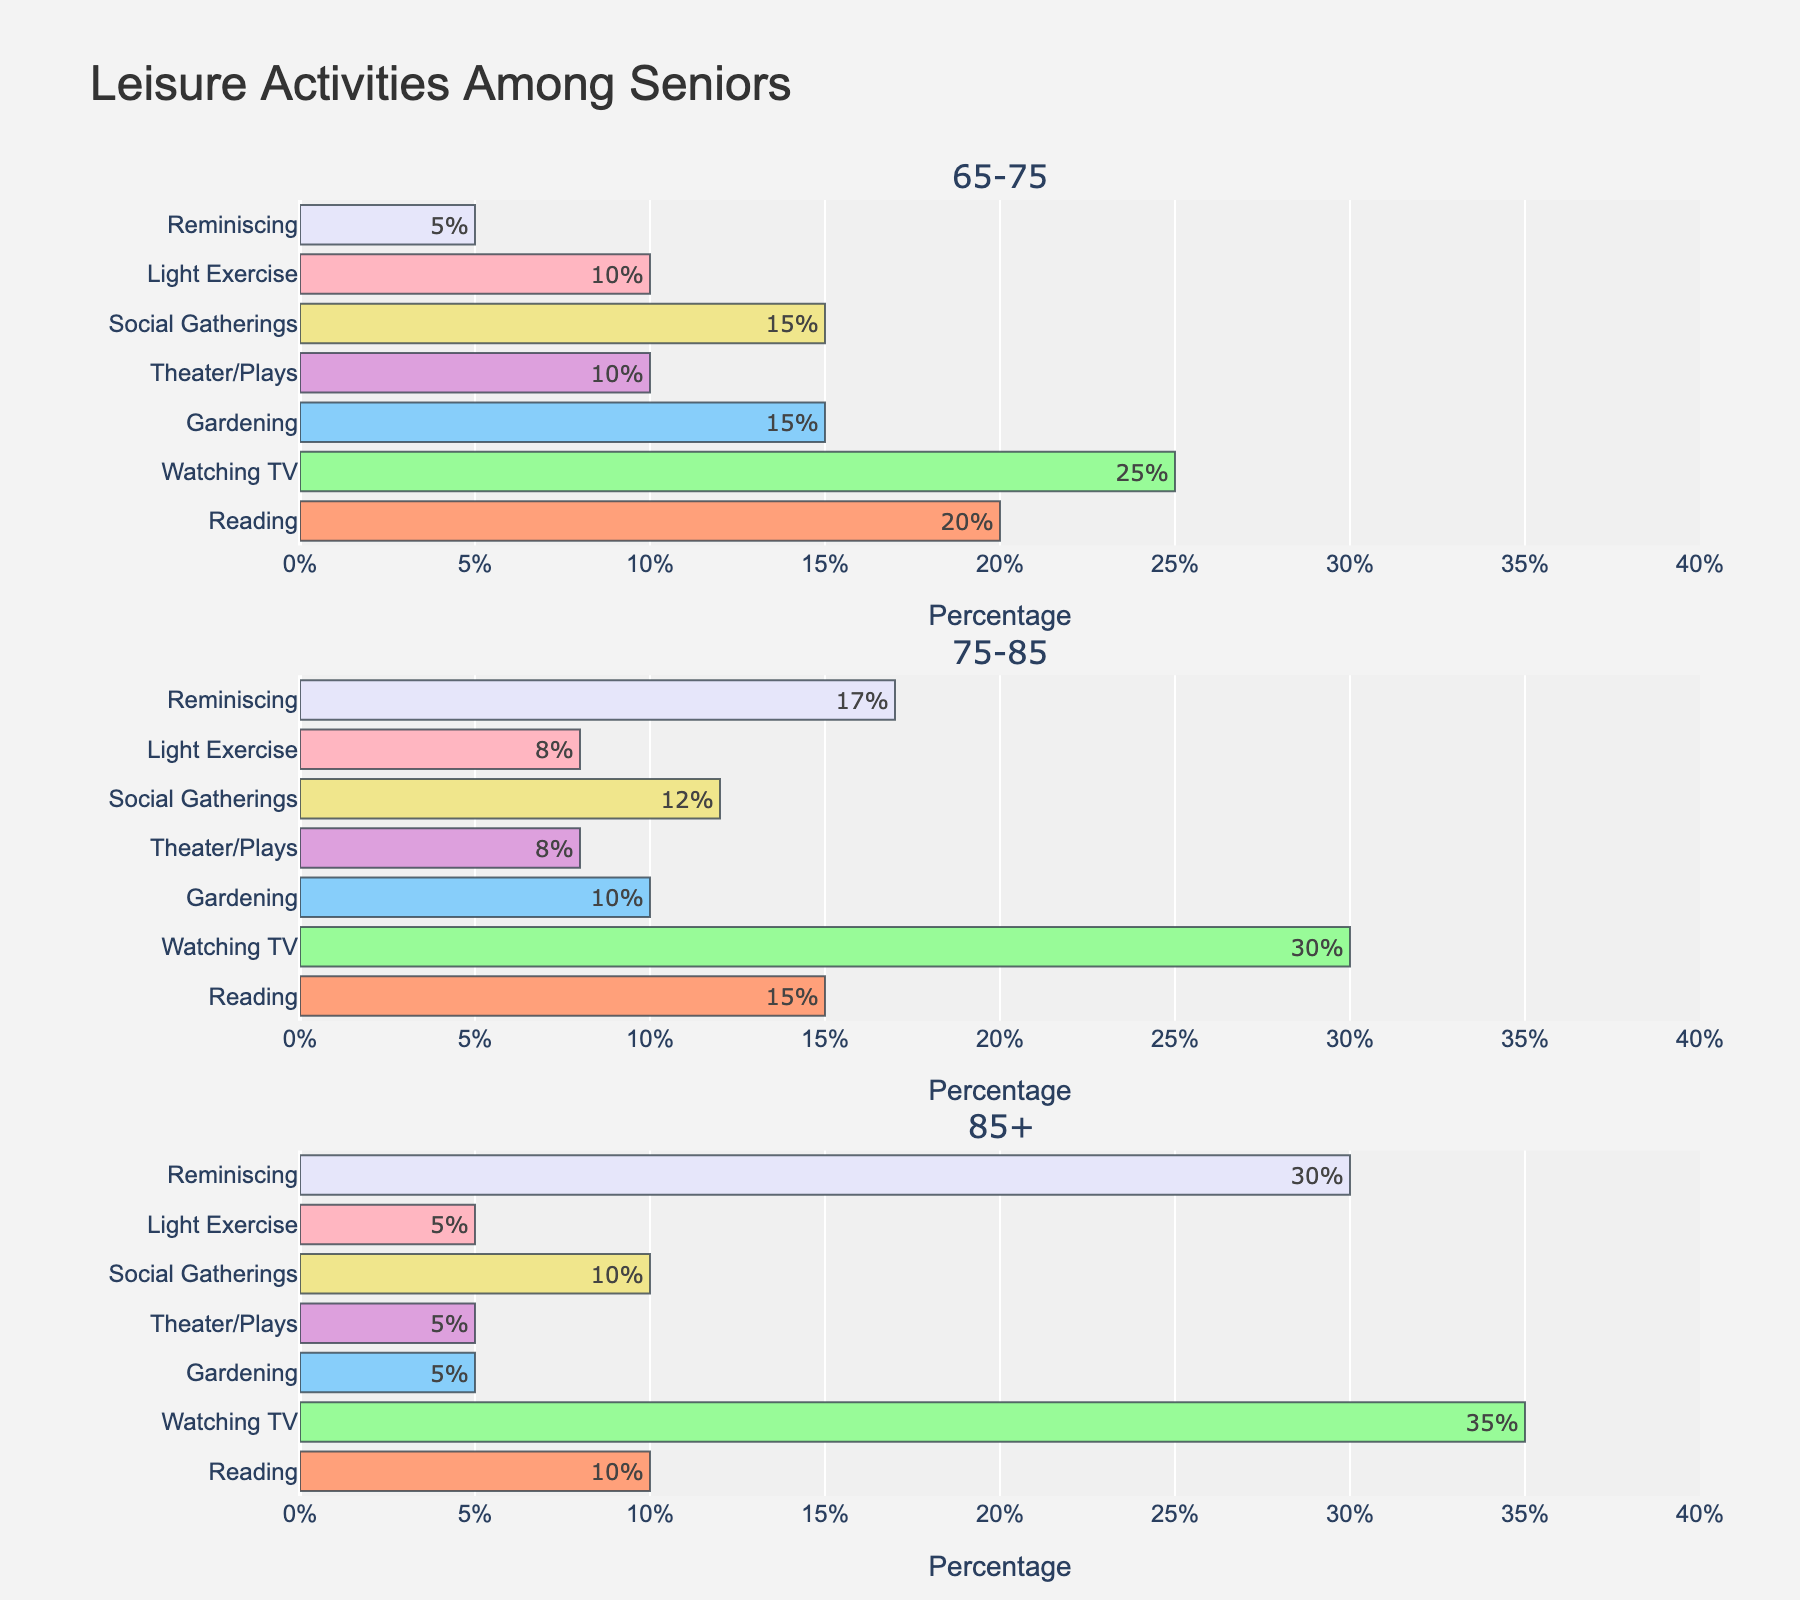What is the title of the figure? The title is typically located at the top of the plot. It provides a summary or overview of what the figure represents.
Answer: Leisure Activities Among Seniors Which age group spends the highest percentage of their leisure time watching TV? The bar for "Watching TV" needs to be directly compared across all age groups to find the highest percentage.
Answer: 85+ What percentage of the 65-75 age group enjoys gardening? By looking at the "Gardening" bar for the 65-75 age group, we can determine the percentage.
Answer: 15% How does the percentage of seniors reminiscing differ between the 75-85 and 85+ age groups? We compare the "Reminiscing" bars for these two age groups to find the difference. The 75-85 group has a bar at 17%, while the 85+ group has a bar at 30%.
Answer: 13% more in the 85+ group What is the difference in the percentage of those attending social gatherings between the 65-75 and 85+ age groups? Compare the "Social Gatherings" bars for the two age groups. The 65-75 group has 15%, and the 85+ group has 10%. The difference is calculated by subtracting the lower percentage from the higher one.
Answer: 5% Which activity shows the greatest increase in percentage from the 65-75 age group to the 85+ age group? We need to calculate the difference for each activity between these two age groups and identify the activity with the highest positive difference. For "Reading" it's a decrease, "Watching TV" increases by 10%, "Gardening" decreases, "Theater/Plays" decreases, "Social Gatherings" decreases by 5%, "Light Exercise" decreases, and "Reminiscing" increases by 25%. So "Reminiscing" increases the most.
Answer: Reminiscing In the 75-85 age group, which activity has the lowest participation percentage? We need to scan the bars for this age group and find the one with the smallest value. The corresponding values are: "Reading" 15%, "Watching TV" 30%, "Gardening" 10%, "Theater/Plays" 8%, "Social Gatherings" 12%, "Light Exercise" 8%, and "Reminiscing" 17%. The smallest percentage here is 8%, which is shared by "Theater/Plays” and “Light Exercise"
Answer: Theater/Plays and Light Exercise What is the total percentage of the leisure activities for the 85+ age group? The percentages for each activity in this age group are summed up. Adding up 10% (Reading) + 35% (Watching TV) + 5% (Gardening) + 5% (Theater/Plays) + 10% (Social Gatherings) + 5% (Light Exercise) + 30% (Reminiscing) gives 100%.
Answer: 100% Which age group has the most balanced distribution of leisure activities, specifically between Reading, Watching TV, Gardening, and Theater/Plays? This requires comparing how evenly distributed these percentages are within each age group. The age group 65-75 has 20%, 25%, 15%, and 10% for these activities, whereas 75-85 has 15%, 30%, 10%, and 8%, and 85+ has 10%, 35%, 5%, and 5%. The most balanced distribution, where the percentages do not vary greatly, is observed in the 65-75 age group.
Answer: 65-75 